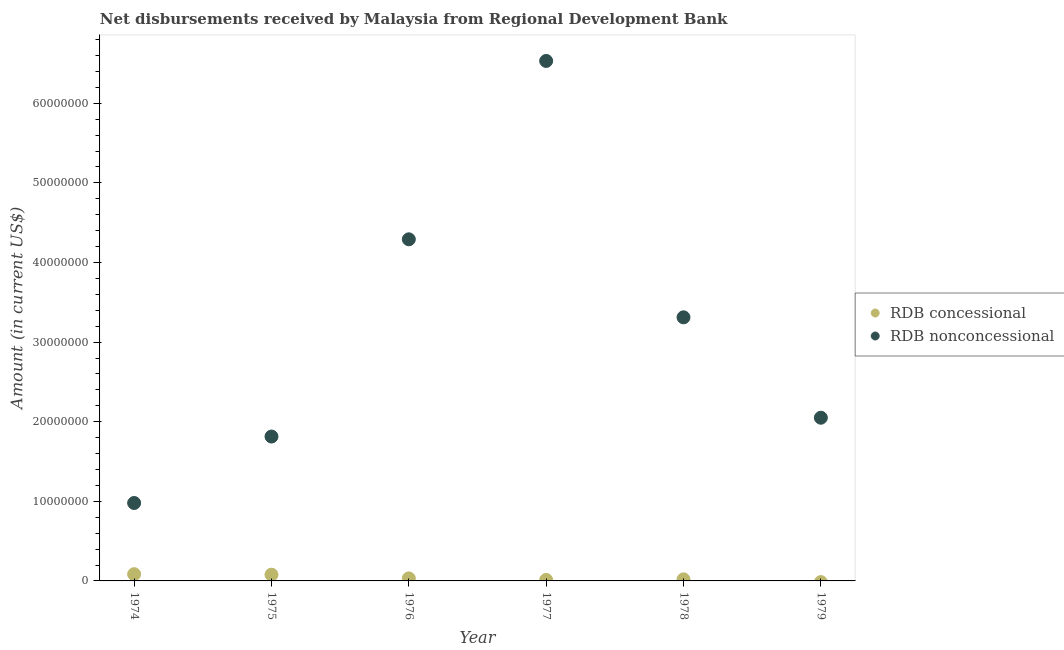Is the number of dotlines equal to the number of legend labels?
Your response must be concise. No. What is the net concessional disbursements from rdb in 1977?
Make the answer very short. 1.26e+05. Across all years, what is the maximum net concessional disbursements from rdb?
Provide a succinct answer. 8.46e+05. In which year was the net concessional disbursements from rdb maximum?
Your answer should be compact. 1974. What is the total net non concessional disbursements from rdb in the graph?
Keep it short and to the point. 1.90e+08. What is the difference between the net concessional disbursements from rdb in 1976 and that in 1978?
Your answer should be compact. 1.21e+05. What is the difference between the net non concessional disbursements from rdb in 1975 and the net concessional disbursements from rdb in 1977?
Make the answer very short. 1.80e+07. What is the average net non concessional disbursements from rdb per year?
Provide a succinct answer. 3.16e+07. In the year 1978, what is the difference between the net concessional disbursements from rdb and net non concessional disbursements from rdb?
Offer a very short reply. -3.29e+07. What is the ratio of the net non concessional disbursements from rdb in 1975 to that in 1978?
Ensure brevity in your answer.  0.55. What is the difference between the highest and the second highest net concessional disbursements from rdb?
Keep it short and to the point. 6.10e+04. What is the difference between the highest and the lowest net concessional disbursements from rdb?
Your answer should be compact. 8.46e+05. In how many years, is the net non concessional disbursements from rdb greater than the average net non concessional disbursements from rdb taken over all years?
Give a very brief answer. 3. How many years are there in the graph?
Make the answer very short. 6. What is the difference between two consecutive major ticks on the Y-axis?
Your answer should be very brief. 1.00e+07. Are the values on the major ticks of Y-axis written in scientific E-notation?
Provide a succinct answer. No. Where does the legend appear in the graph?
Make the answer very short. Center right. How many legend labels are there?
Your answer should be very brief. 2. What is the title of the graph?
Offer a terse response. Net disbursements received by Malaysia from Regional Development Bank. Does "Netherlands" appear as one of the legend labels in the graph?
Ensure brevity in your answer.  No. What is the label or title of the X-axis?
Your answer should be compact. Year. What is the label or title of the Y-axis?
Your response must be concise. Amount (in current US$). What is the Amount (in current US$) of RDB concessional in 1974?
Keep it short and to the point. 8.46e+05. What is the Amount (in current US$) of RDB nonconcessional in 1974?
Your answer should be very brief. 9.79e+06. What is the Amount (in current US$) of RDB concessional in 1975?
Offer a terse response. 7.85e+05. What is the Amount (in current US$) of RDB nonconcessional in 1975?
Give a very brief answer. 1.81e+07. What is the Amount (in current US$) of RDB concessional in 1976?
Make the answer very short. 3.18e+05. What is the Amount (in current US$) of RDB nonconcessional in 1976?
Ensure brevity in your answer.  4.29e+07. What is the Amount (in current US$) of RDB concessional in 1977?
Ensure brevity in your answer.  1.26e+05. What is the Amount (in current US$) of RDB nonconcessional in 1977?
Your answer should be very brief. 6.53e+07. What is the Amount (in current US$) of RDB concessional in 1978?
Ensure brevity in your answer.  1.97e+05. What is the Amount (in current US$) of RDB nonconcessional in 1978?
Give a very brief answer. 3.31e+07. What is the Amount (in current US$) of RDB concessional in 1979?
Your answer should be compact. 0. What is the Amount (in current US$) in RDB nonconcessional in 1979?
Your response must be concise. 2.05e+07. Across all years, what is the maximum Amount (in current US$) in RDB concessional?
Your answer should be very brief. 8.46e+05. Across all years, what is the maximum Amount (in current US$) in RDB nonconcessional?
Offer a very short reply. 6.53e+07. Across all years, what is the minimum Amount (in current US$) of RDB nonconcessional?
Offer a terse response. 9.79e+06. What is the total Amount (in current US$) in RDB concessional in the graph?
Provide a short and direct response. 2.27e+06. What is the total Amount (in current US$) in RDB nonconcessional in the graph?
Your answer should be very brief. 1.90e+08. What is the difference between the Amount (in current US$) of RDB concessional in 1974 and that in 1975?
Offer a very short reply. 6.10e+04. What is the difference between the Amount (in current US$) of RDB nonconcessional in 1974 and that in 1975?
Offer a terse response. -8.35e+06. What is the difference between the Amount (in current US$) of RDB concessional in 1974 and that in 1976?
Ensure brevity in your answer.  5.28e+05. What is the difference between the Amount (in current US$) in RDB nonconcessional in 1974 and that in 1976?
Make the answer very short. -3.31e+07. What is the difference between the Amount (in current US$) of RDB concessional in 1974 and that in 1977?
Give a very brief answer. 7.20e+05. What is the difference between the Amount (in current US$) of RDB nonconcessional in 1974 and that in 1977?
Provide a succinct answer. -5.55e+07. What is the difference between the Amount (in current US$) of RDB concessional in 1974 and that in 1978?
Make the answer very short. 6.49e+05. What is the difference between the Amount (in current US$) in RDB nonconcessional in 1974 and that in 1978?
Keep it short and to the point. -2.33e+07. What is the difference between the Amount (in current US$) of RDB nonconcessional in 1974 and that in 1979?
Keep it short and to the point. -1.07e+07. What is the difference between the Amount (in current US$) in RDB concessional in 1975 and that in 1976?
Provide a succinct answer. 4.67e+05. What is the difference between the Amount (in current US$) of RDB nonconcessional in 1975 and that in 1976?
Provide a succinct answer. -2.48e+07. What is the difference between the Amount (in current US$) of RDB concessional in 1975 and that in 1977?
Keep it short and to the point. 6.59e+05. What is the difference between the Amount (in current US$) of RDB nonconcessional in 1975 and that in 1977?
Provide a succinct answer. -4.72e+07. What is the difference between the Amount (in current US$) in RDB concessional in 1975 and that in 1978?
Keep it short and to the point. 5.88e+05. What is the difference between the Amount (in current US$) of RDB nonconcessional in 1975 and that in 1978?
Your answer should be compact. -1.50e+07. What is the difference between the Amount (in current US$) in RDB nonconcessional in 1975 and that in 1979?
Your response must be concise. -2.36e+06. What is the difference between the Amount (in current US$) in RDB concessional in 1976 and that in 1977?
Offer a terse response. 1.92e+05. What is the difference between the Amount (in current US$) in RDB nonconcessional in 1976 and that in 1977?
Your answer should be compact. -2.24e+07. What is the difference between the Amount (in current US$) in RDB concessional in 1976 and that in 1978?
Offer a terse response. 1.21e+05. What is the difference between the Amount (in current US$) in RDB nonconcessional in 1976 and that in 1978?
Your answer should be very brief. 9.80e+06. What is the difference between the Amount (in current US$) of RDB nonconcessional in 1976 and that in 1979?
Provide a short and direct response. 2.24e+07. What is the difference between the Amount (in current US$) in RDB concessional in 1977 and that in 1978?
Make the answer very short. -7.10e+04. What is the difference between the Amount (in current US$) of RDB nonconcessional in 1977 and that in 1978?
Ensure brevity in your answer.  3.22e+07. What is the difference between the Amount (in current US$) in RDB nonconcessional in 1977 and that in 1979?
Offer a terse response. 4.48e+07. What is the difference between the Amount (in current US$) of RDB nonconcessional in 1978 and that in 1979?
Your response must be concise. 1.26e+07. What is the difference between the Amount (in current US$) in RDB concessional in 1974 and the Amount (in current US$) in RDB nonconcessional in 1975?
Your answer should be very brief. -1.73e+07. What is the difference between the Amount (in current US$) in RDB concessional in 1974 and the Amount (in current US$) in RDB nonconcessional in 1976?
Ensure brevity in your answer.  -4.21e+07. What is the difference between the Amount (in current US$) of RDB concessional in 1974 and the Amount (in current US$) of RDB nonconcessional in 1977?
Offer a very short reply. -6.45e+07. What is the difference between the Amount (in current US$) in RDB concessional in 1974 and the Amount (in current US$) in RDB nonconcessional in 1978?
Offer a terse response. -3.23e+07. What is the difference between the Amount (in current US$) of RDB concessional in 1974 and the Amount (in current US$) of RDB nonconcessional in 1979?
Provide a succinct answer. -1.97e+07. What is the difference between the Amount (in current US$) of RDB concessional in 1975 and the Amount (in current US$) of RDB nonconcessional in 1976?
Provide a succinct answer. -4.21e+07. What is the difference between the Amount (in current US$) in RDB concessional in 1975 and the Amount (in current US$) in RDB nonconcessional in 1977?
Offer a very short reply. -6.45e+07. What is the difference between the Amount (in current US$) of RDB concessional in 1975 and the Amount (in current US$) of RDB nonconcessional in 1978?
Make the answer very short. -3.23e+07. What is the difference between the Amount (in current US$) in RDB concessional in 1975 and the Amount (in current US$) in RDB nonconcessional in 1979?
Offer a terse response. -1.97e+07. What is the difference between the Amount (in current US$) in RDB concessional in 1976 and the Amount (in current US$) in RDB nonconcessional in 1977?
Your answer should be compact. -6.50e+07. What is the difference between the Amount (in current US$) in RDB concessional in 1976 and the Amount (in current US$) in RDB nonconcessional in 1978?
Make the answer very short. -3.28e+07. What is the difference between the Amount (in current US$) of RDB concessional in 1976 and the Amount (in current US$) of RDB nonconcessional in 1979?
Provide a succinct answer. -2.02e+07. What is the difference between the Amount (in current US$) in RDB concessional in 1977 and the Amount (in current US$) in RDB nonconcessional in 1978?
Provide a succinct answer. -3.30e+07. What is the difference between the Amount (in current US$) of RDB concessional in 1977 and the Amount (in current US$) of RDB nonconcessional in 1979?
Your answer should be very brief. -2.04e+07. What is the difference between the Amount (in current US$) in RDB concessional in 1978 and the Amount (in current US$) in RDB nonconcessional in 1979?
Your answer should be very brief. -2.03e+07. What is the average Amount (in current US$) of RDB concessional per year?
Keep it short and to the point. 3.79e+05. What is the average Amount (in current US$) in RDB nonconcessional per year?
Offer a terse response. 3.16e+07. In the year 1974, what is the difference between the Amount (in current US$) in RDB concessional and Amount (in current US$) in RDB nonconcessional?
Your response must be concise. -8.94e+06. In the year 1975, what is the difference between the Amount (in current US$) of RDB concessional and Amount (in current US$) of RDB nonconcessional?
Provide a short and direct response. -1.74e+07. In the year 1976, what is the difference between the Amount (in current US$) of RDB concessional and Amount (in current US$) of RDB nonconcessional?
Give a very brief answer. -4.26e+07. In the year 1977, what is the difference between the Amount (in current US$) of RDB concessional and Amount (in current US$) of RDB nonconcessional?
Make the answer very short. -6.52e+07. In the year 1978, what is the difference between the Amount (in current US$) of RDB concessional and Amount (in current US$) of RDB nonconcessional?
Keep it short and to the point. -3.29e+07. What is the ratio of the Amount (in current US$) of RDB concessional in 1974 to that in 1975?
Offer a very short reply. 1.08. What is the ratio of the Amount (in current US$) of RDB nonconcessional in 1974 to that in 1975?
Provide a short and direct response. 0.54. What is the ratio of the Amount (in current US$) of RDB concessional in 1974 to that in 1976?
Give a very brief answer. 2.66. What is the ratio of the Amount (in current US$) in RDB nonconcessional in 1974 to that in 1976?
Make the answer very short. 0.23. What is the ratio of the Amount (in current US$) in RDB concessional in 1974 to that in 1977?
Provide a short and direct response. 6.71. What is the ratio of the Amount (in current US$) of RDB nonconcessional in 1974 to that in 1977?
Your response must be concise. 0.15. What is the ratio of the Amount (in current US$) in RDB concessional in 1974 to that in 1978?
Offer a very short reply. 4.29. What is the ratio of the Amount (in current US$) of RDB nonconcessional in 1974 to that in 1978?
Give a very brief answer. 0.3. What is the ratio of the Amount (in current US$) in RDB nonconcessional in 1974 to that in 1979?
Your response must be concise. 0.48. What is the ratio of the Amount (in current US$) of RDB concessional in 1975 to that in 1976?
Offer a very short reply. 2.47. What is the ratio of the Amount (in current US$) in RDB nonconcessional in 1975 to that in 1976?
Offer a very short reply. 0.42. What is the ratio of the Amount (in current US$) of RDB concessional in 1975 to that in 1977?
Provide a short and direct response. 6.23. What is the ratio of the Amount (in current US$) of RDB nonconcessional in 1975 to that in 1977?
Provide a short and direct response. 0.28. What is the ratio of the Amount (in current US$) of RDB concessional in 1975 to that in 1978?
Make the answer very short. 3.98. What is the ratio of the Amount (in current US$) in RDB nonconcessional in 1975 to that in 1978?
Give a very brief answer. 0.55. What is the ratio of the Amount (in current US$) of RDB nonconcessional in 1975 to that in 1979?
Keep it short and to the point. 0.88. What is the ratio of the Amount (in current US$) in RDB concessional in 1976 to that in 1977?
Make the answer very short. 2.52. What is the ratio of the Amount (in current US$) of RDB nonconcessional in 1976 to that in 1977?
Offer a terse response. 0.66. What is the ratio of the Amount (in current US$) in RDB concessional in 1976 to that in 1978?
Your answer should be very brief. 1.61. What is the ratio of the Amount (in current US$) in RDB nonconcessional in 1976 to that in 1978?
Offer a very short reply. 1.3. What is the ratio of the Amount (in current US$) of RDB nonconcessional in 1976 to that in 1979?
Provide a succinct answer. 2.09. What is the ratio of the Amount (in current US$) in RDB concessional in 1977 to that in 1978?
Your answer should be compact. 0.64. What is the ratio of the Amount (in current US$) in RDB nonconcessional in 1977 to that in 1978?
Your response must be concise. 1.97. What is the ratio of the Amount (in current US$) in RDB nonconcessional in 1977 to that in 1979?
Make the answer very short. 3.19. What is the ratio of the Amount (in current US$) in RDB nonconcessional in 1978 to that in 1979?
Offer a terse response. 1.62. What is the difference between the highest and the second highest Amount (in current US$) in RDB concessional?
Your response must be concise. 6.10e+04. What is the difference between the highest and the second highest Amount (in current US$) of RDB nonconcessional?
Offer a very short reply. 2.24e+07. What is the difference between the highest and the lowest Amount (in current US$) in RDB concessional?
Offer a very short reply. 8.46e+05. What is the difference between the highest and the lowest Amount (in current US$) in RDB nonconcessional?
Your answer should be compact. 5.55e+07. 